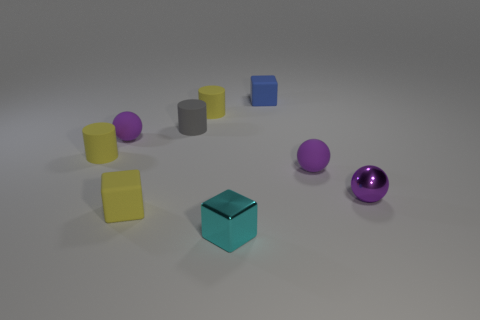How many spheres are present in the image, and do they share the same size? There are two spheres in the image, one purple and one metallic. They do not share the same size; the purple sphere is larger than the metallic one. 